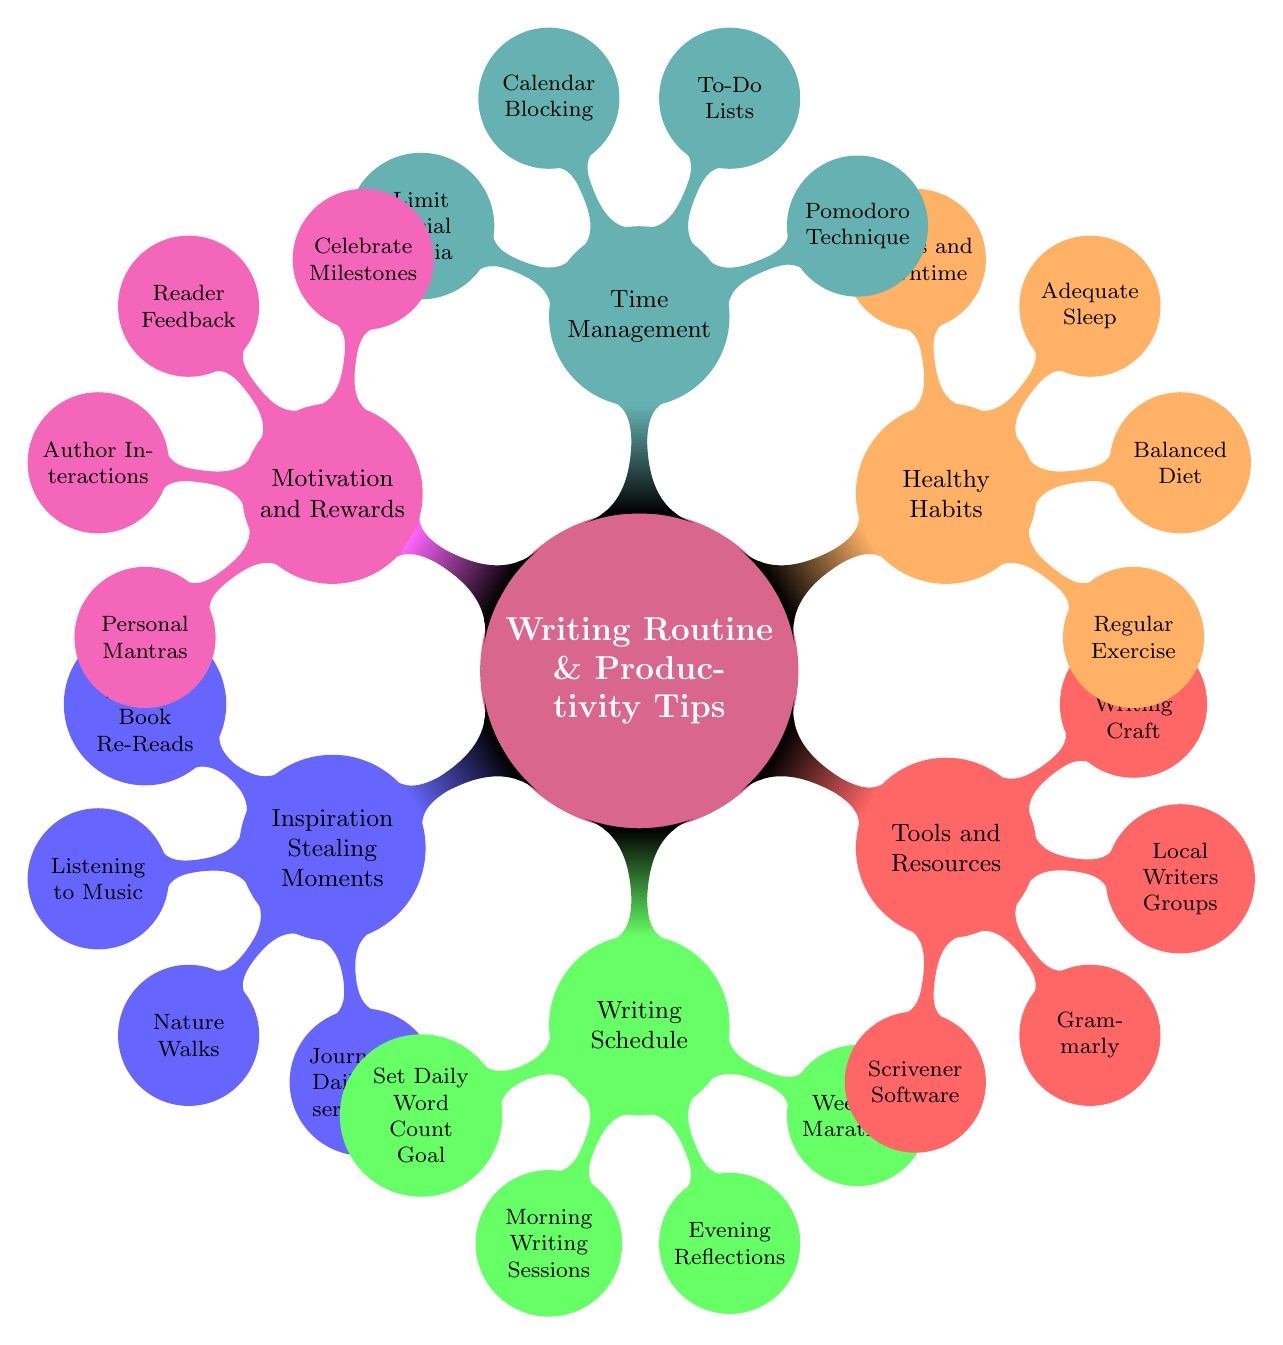What are the two main categories in the main node? The main node branches into six categories: Inspiration Stealing Moments and Writing Schedule, Tools and Resources, Healthy Habits, Time Management, and Motivation and Rewards.
Answer: Inspiration Stealing Moments, Writing Schedule How many tips are listed under Healthy Habits? The Healthy Habits node contains four tips: Regular Exercise, Balanced Diet, Adequate Sleep, and Breaks and Downtime.
Answer: 4 Which tool is suggested for organizing manuscript? The Tools and Resources node includes Scrivener Software, which is specifically mentioned for organizing the manuscript.
Answer: Scrivener Software What activity is recommended to maintain energy levels? The Healthy Habits section lists Balanced Diet as the activity specifically mentioned for maintaining energy levels.
Answer: Balanced Diet What writing tip is suggested for utilizing fresh mind? The Writing Schedule node mentions Morning Writing Sessions as a tip that focuses on writing when the mind is fresh.
Answer: Morning Writing Sessions Which time management technique helps reduce distractions? The Time Management category includes Limit Social Media as a technique aimed at reducing distractions during writing.
Answer: Limit Social Media What is the purpose of celebrating milestones? Within the Motivation and Rewards section, celebrating milestones serves to reward achievements related to writing, such as publishing milestones.
Answer: Reward achievements How many tips are there under Time Management? The Time Management node details four tips: Pomodoro Technique, To-Do Lists, Calendar Blocking, and Limit Social Media, totaling four tips.
Answer: 4 What type of writer groups are suggested for peer feedback? The Tools and Resources category identifies Local Writers Groups as a means to gain peer feedback, particularly mentioning resources like Meetup or local library programs.
Answer: Local Writers Groups 